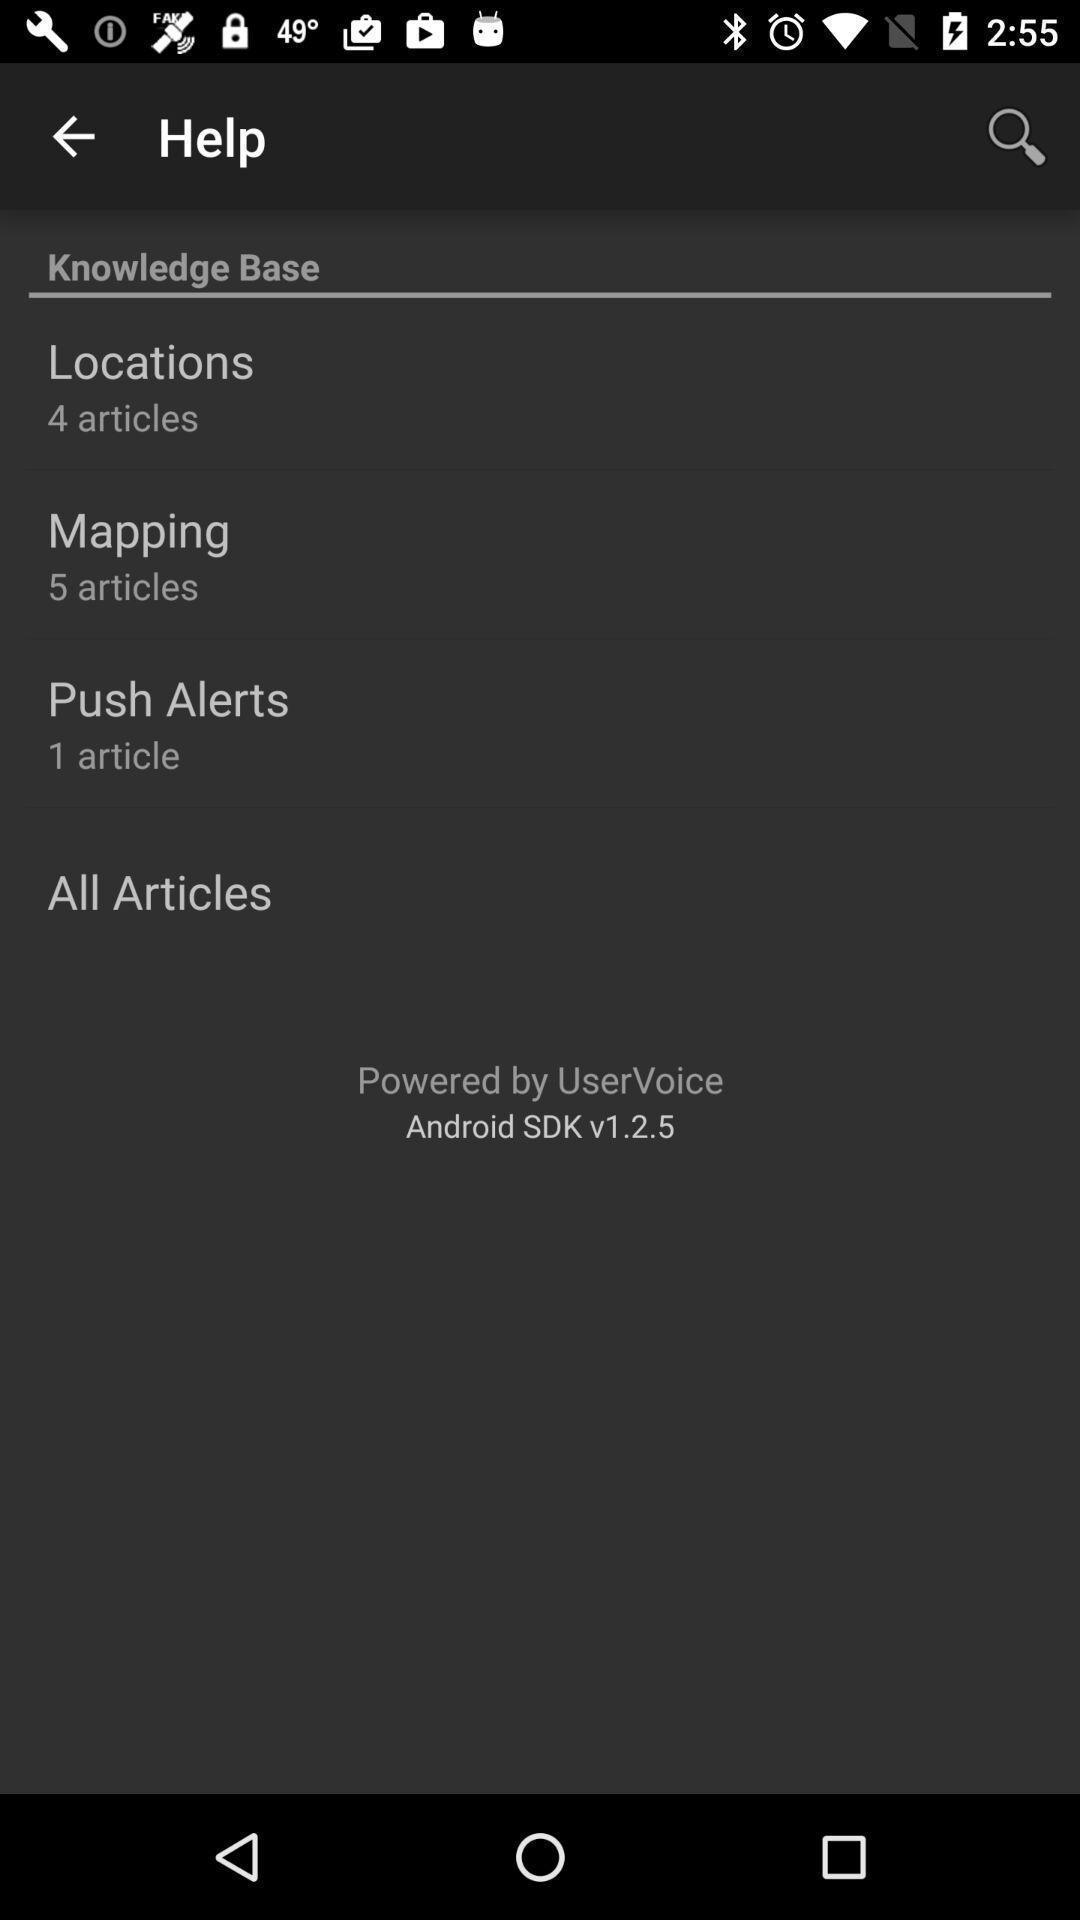Provide a description of this screenshot. Screen displaying the help page. 